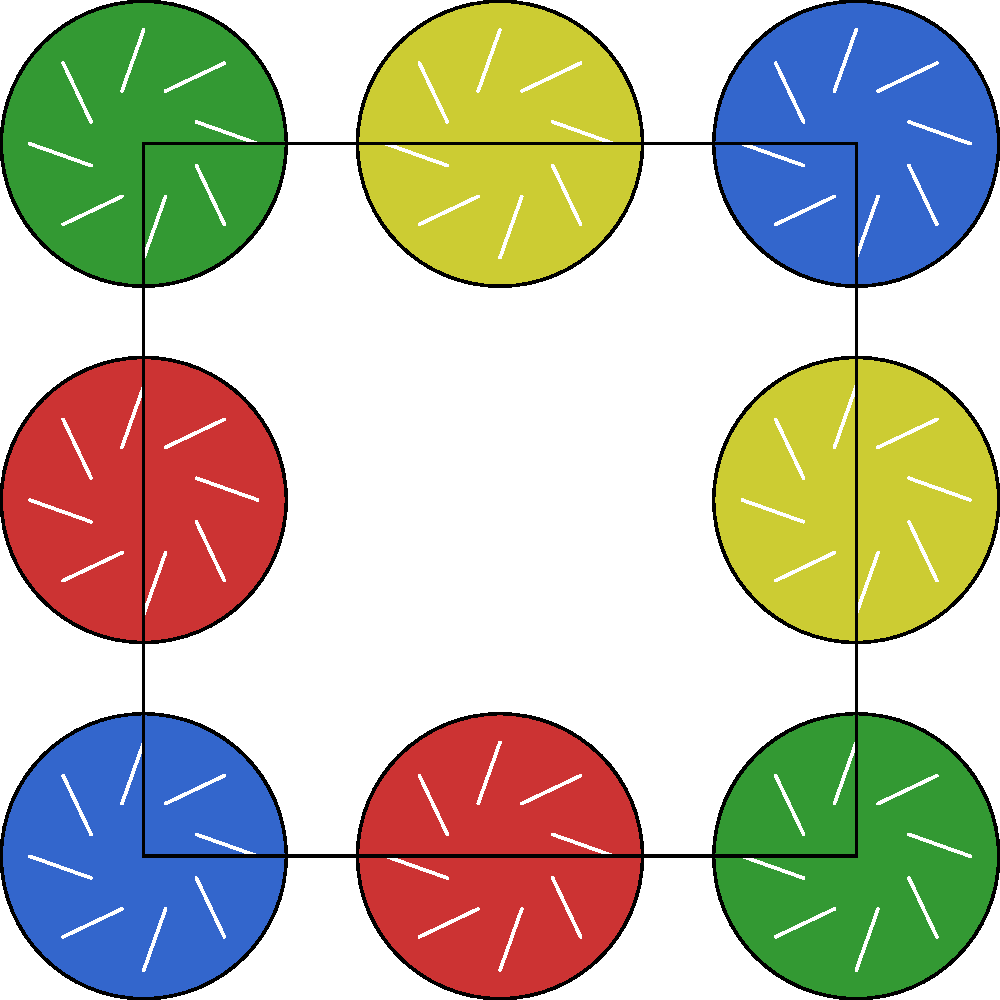In this traditional mosaic pattern from the Middle East, which color should fill the missing central tile to maintain the pattern's symmetry and cultural significance? To determine the correct color for the missing central tile, we need to analyze the pattern:

1. The mosaic follows a 3x3 grid pattern with alternating colors.
2. Each tile contains an eight-pointed star, a common motif in Islamic art symbolizing the eight gates of paradise.
3. The colors alternate in a diagonal pattern:
   - Top-left: Blue
   - Top-middle: Red
   - Top-right: Green
   - Middle-left: Green
   - Middle-right: Blue
   - Bottom-left: Yellow
   - Bottom-middle: Green
   - Bottom-right: Red

4. To maintain symmetry, the central tile should complete the pattern:
   - It should be different from its adjacent tiles (Red, Green, Blue, and Yellow).
   - The only color that satisfies this condition and maintains the diagonal pattern is Yellow.

5. In Islamic art, yellow often represents wisdom and prosperity, which would be fitting for the central tile in this culturally significant pattern.

Therefore, the missing central tile should be Yellow to maintain both the geometric symmetry and the cultural symbolism of the mosaic.
Answer: Yellow 